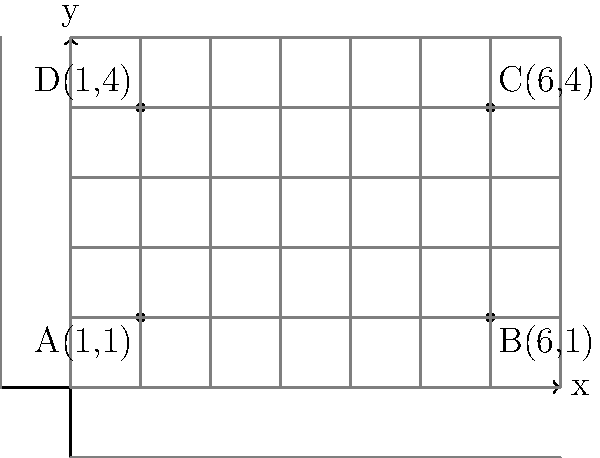Your older sibling is helping you measure a rectangular room for a DIY project. They've marked the corners of the room on a coordinate grid, as shown in the diagram. The corners are at points A(1,1), B(6,1), C(6,4), and D(1,4). Can you calculate the area of the room? Let's approach this step-by-step:

1) To find the area of a rectangle, we need its length and width.

2) The length of the room is the distance between points A and B (or D and C).
   We can calculate this by subtracting the x-coordinates:
   Length = $6 - 1 = 5$ units

3) The width of the room is the distance between points A and D (or B and C).
   We can calculate this by subtracting the y-coordinates:
   Width = $4 - 1 = 3$ units

4) Now that we have the length and width, we can calculate the area:
   Area = Length × Width
   Area = $5 \times 3 = 15$ square units

Therefore, the area of the room is 15 square units.
Answer: 15 square units 